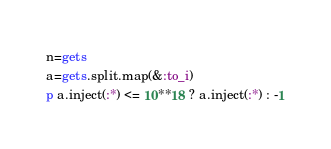Convert code to text. <code><loc_0><loc_0><loc_500><loc_500><_Ruby_>n=gets
a=gets.split.map(&:to_i)
p a.inject(:*) <= 10**18 ? a.inject(:*) : -1</code> 